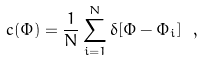Convert formula to latex. <formula><loc_0><loc_0><loc_500><loc_500>c ( \Phi ) = \frac { 1 } { N } \sum _ { i = 1 } ^ { N } \delta [ \Phi - \Phi _ { i } ] \ ,</formula> 